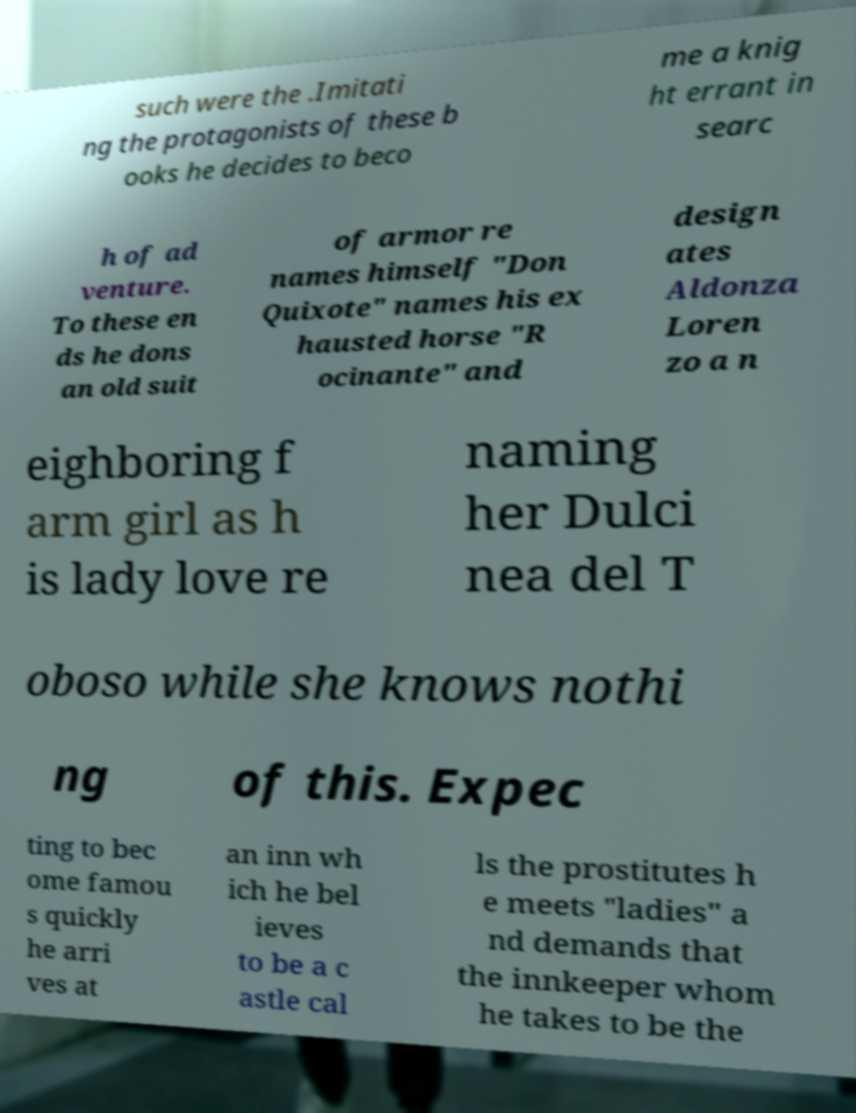What messages or text are displayed in this image? I need them in a readable, typed format. such were the .Imitati ng the protagonists of these b ooks he decides to beco me a knig ht errant in searc h of ad venture. To these en ds he dons an old suit of armor re names himself "Don Quixote" names his ex hausted horse "R ocinante" and design ates Aldonza Loren zo a n eighboring f arm girl as h is lady love re naming her Dulci nea del T oboso while she knows nothi ng of this. Expec ting to bec ome famou s quickly he arri ves at an inn wh ich he bel ieves to be a c astle cal ls the prostitutes h e meets "ladies" a nd demands that the innkeeper whom he takes to be the 